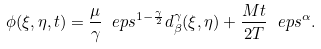<formula> <loc_0><loc_0><loc_500><loc_500>\phi ( \xi , \eta , t ) = \frac { \mu } { \gamma } \ e p s ^ { 1 - \frac { \gamma } { 2 } } d _ { \beta } ^ { \gamma } ( \xi , \eta ) + \frac { M t } { 2 T } \ e p s ^ { \alpha } .</formula> 